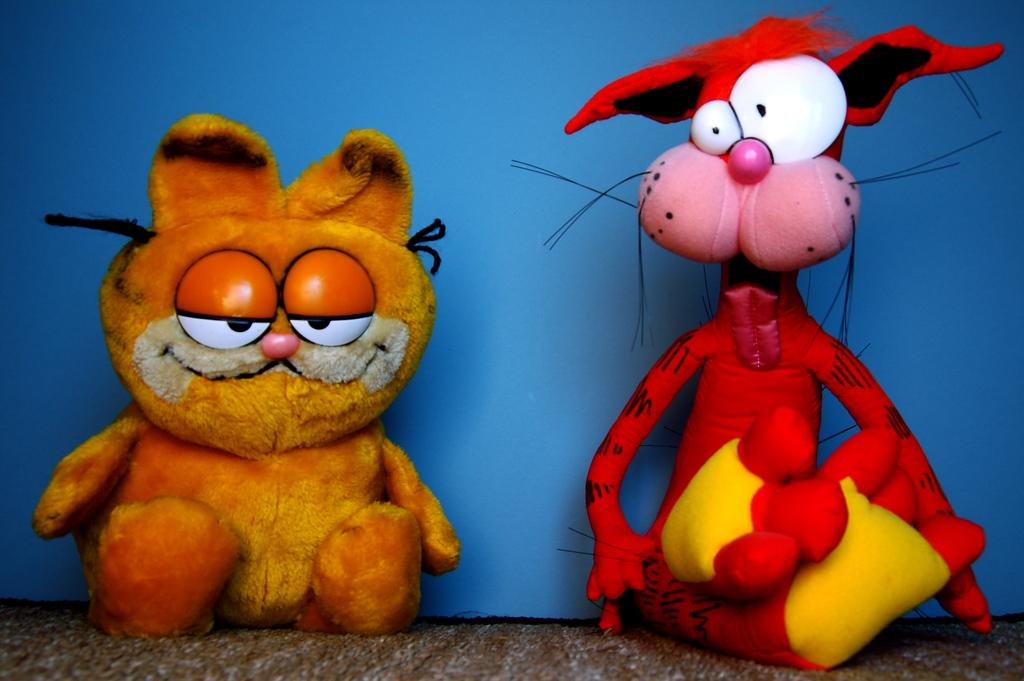How many toys can be seen in the image? There are two toys in the image. Where are the toys located? The toys are on a mat. What can be seen in the background of the image? There is a blue curtain in the background of the image. What type of sponge is being offered to the toys in the image? There is no sponge present in the image, and the toys are not interacting with any objects. 